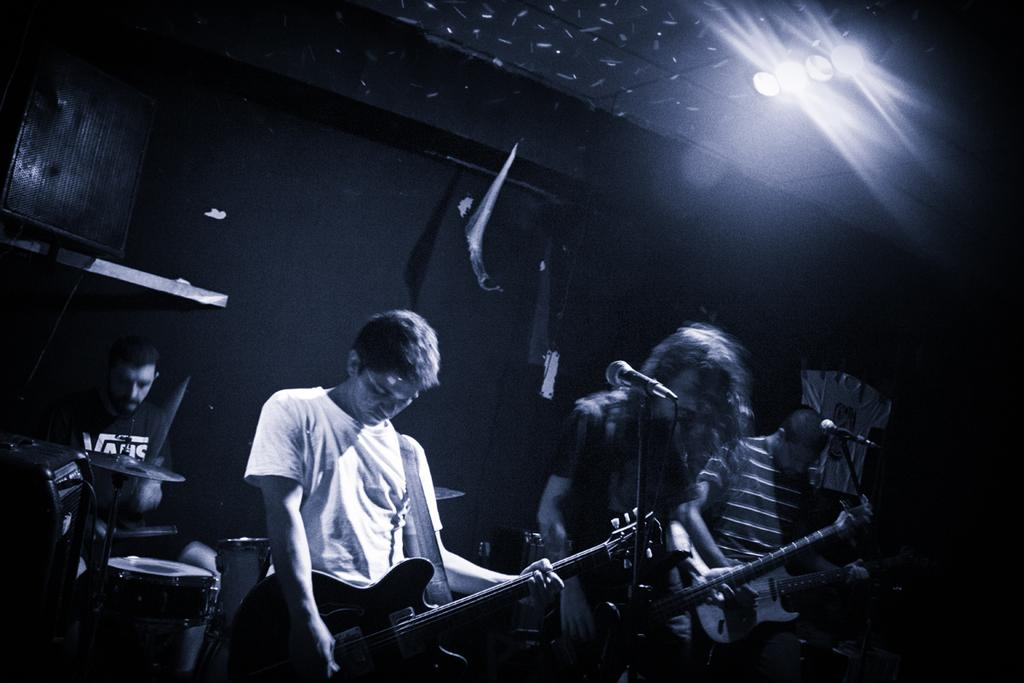What are the people in the image doing? The people in the image are holding musical instruments. Can you describe the background of the image? There is a man sitting next to a drum set in the background. How many microphones are visible in the image? There are two microphones visible in the image. How many horses can be seen tied to the string in the image? There are no horses or strings present in the image. 